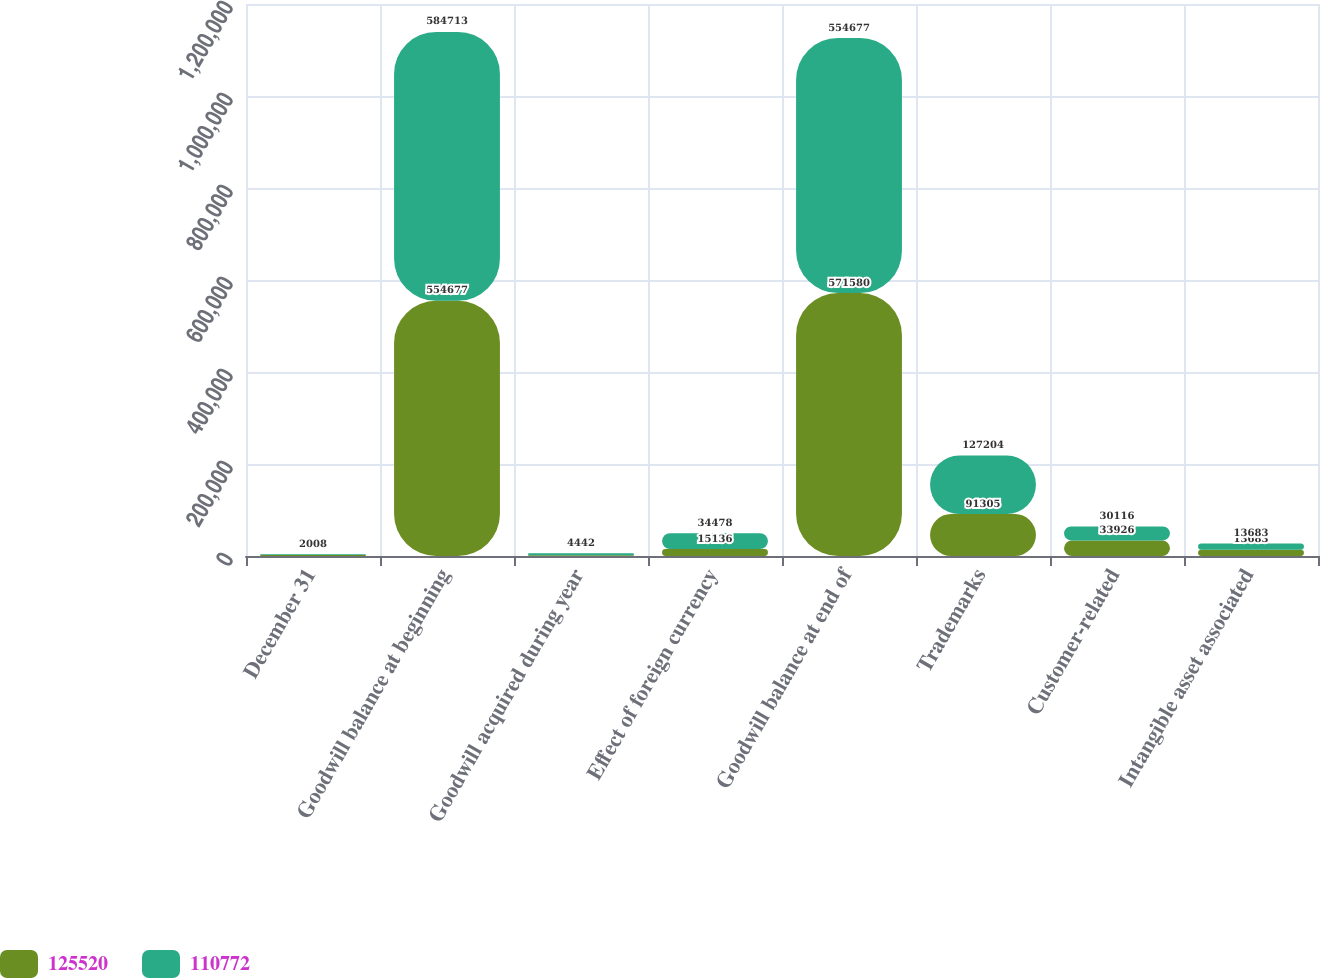<chart> <loc_0><loc_0><loc_500><loc_500><stacked_bar_chart><ecel><fcel>December 31<fcel>Goodwill balance at beginning<fcel>Goodwill acquired during year<fcel>Effect of foreign currency<fcel>Goodwill balance at end of<fcel>Trademarks<fcel>Customer-related<fcel>Intangible asset associated<nl><fcel>125520<fcel>2009<fcel>554677<fcel>1767<fcel>15136<fcel>571580<fcel>91305<fcel>33926<fcel>13683<nl><fcel>110772<fcel>2008<fcel>584713<fcel>4442<fcel>34478<fcel>554677<fcel>127204<fcel>30116<fcel>13683<nl></chart> 